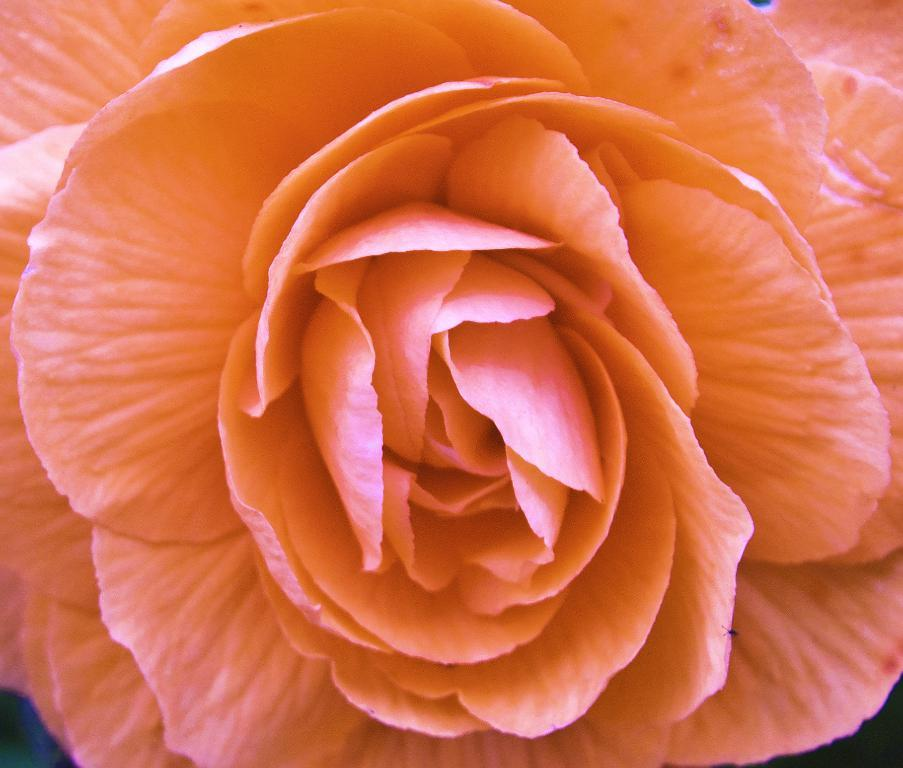What is the main subject of the image? There is a flower in the image. Can you describe the color of the flower? The flower is light orange in color. What is the name of the person holding the flower in the image? There is no person holding the flower in the image; it is a standalone flower. 